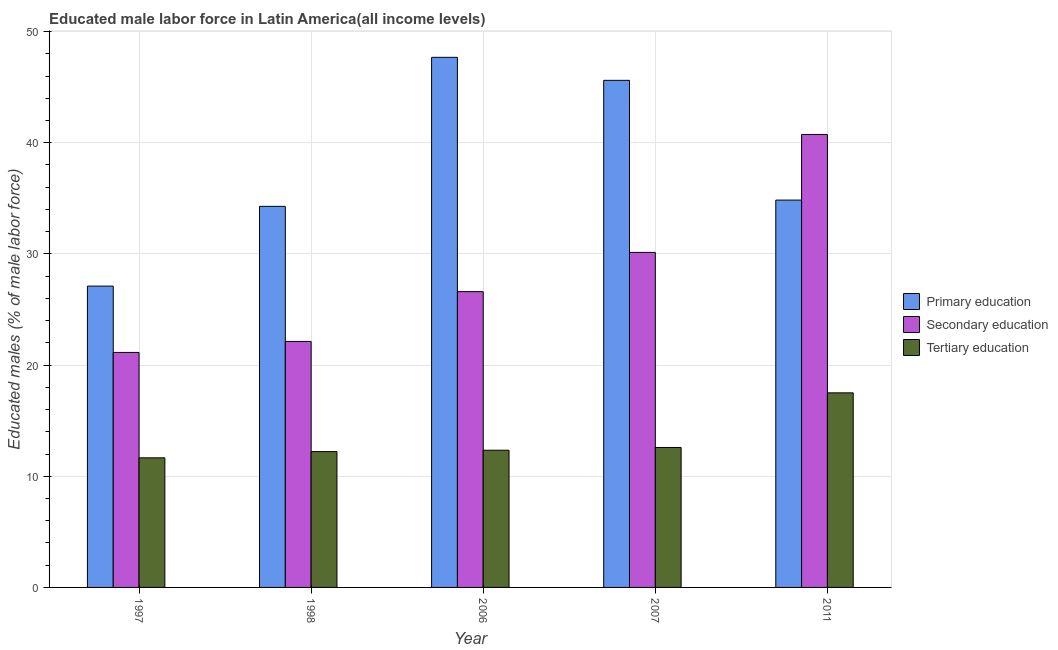How many groups of bars are there?
Provide a succinct answer. 5. Are the number of bars per tick equal to the number of legend labels?
Offer a very short reply. Yes. Are the number of bars on each tick of the X-axis equal?
Ensure brevity in your answer.  Yes. How many bars are there on the 5th tick from the left?
Make the answer very short. 3. What is the label of the 2nd group of bars from the left?
Ensure brevity in your answer.  1998. What is the percentage of male labor force who received secondary education in 2006?
Ensure brevity in your answer.  26.6. Across all years, what is the maximum percentage of male labor force who received tertiary education?
Offer a very short reply. 17.5. Across all years, what is the minimum percentage of male labor force who received primary education?
Your answer should be very brief. 27.1. In which year was the percentage of male labor force who received tertiary education maximum?
Provide a succinct answer. 2011. In which year was the percentage of male labor force who received primary education minimum?
Give a very brief answer. 1997. What is the total percentage of male labor force who received tertiary education in the graph?
Your answer should be very brief. 66.3. What is the difference between the percentage of male labor force who received primary education in 1997 and that in 2007?
Provide a short and direct response. -18.51. What is the difference between the percentage of male labor force who received tertiary education in 2007 and the percentage of male labor force who received secondary education in 2006?
Provide a succinct answer. 0.25. What is the average percentage of male labor force who received secondary education per year?
Your answer should be compact. 28.15. In the year 2007, what is the difference between the percentage of male labor force who received secondary education and percentage of male labor force who received tertiary education?
Provide a succinct answer. 0. In how many years, is the percentage of male labor force who received primary education greater than 8 %?
Give a very brief answer. 5. What is the ratio of the percentage of male labor force who received secondary education in 2006 to that in 2011?
Offer a very short reply. 0.65. Is the percentage of male labor force who received secondary education in 1998 less than that in 2007?
Offer a terse response. Yes. What is the difference between the highest and the second highest percentage of male labor force who received tertiary education?
Your response must be concise. 4.91. What is the difference between the highest and the lowest percentage of male labor force who received secondary education?
Provide a short and direct response. 19.61. Is the sum of the percentage of male labor force who received tertiary education in 1997 and 2006 greater than the maximum percentage of male labor force who received primary education across all years?
Ensure brevity in your answer.  Yes. What does the 2nd bar from the left in 1997 represents?
Make the answer very short. Secondary education. Is it the case that in every year, the sum of the percentage of male labor force who received primary education and percentage of male labor force who received secondary education is greater than the percentage of male labor force who received tertiary education?
Keep it short and to the point. Yes. How many bars are there?
Ensure brevity in your answer.  15. Are the values on the major ticks of Y-axis written in scientific E-notation?
Offer a terse response. No. Does the graph contain any zero values?
Provide a short and direct response. No. Does the graph contain grids?
Provide a short and direct response. Yes. How many legend labels are there?
Ensure brevity in your answer.  3. What is the title of the graph?
Give a very brief answer. Educated male labor force in Latin America(all income levels). Does "Agricultural Nitrous Oxide" appear as one of the legend labels in the graph?
Make the answer very short. No. What is the label or title of the X-axis?
Offer a terse response. Year. What is the label or title of the Y-axis?
Ensure brevity in your answer.  Educated males (% of male labor force). What is the Educated males (% of male labor force) of Primary education in 1997?
Provide a succinct answer. 27.1. What is the Educated males (% of male labor force) of Secondary education in 1997?
Make the answer very short. 21.14. What is the Educated males (% of male labor force) of Tertiary education in 1997?
Give a very brief answer. 11.66. What is the Educated males (% of male labor force) in Primary education in 1998?
Give a very brief answer. 34.28. What is the Educated males (% of male labor force) of Secondary education in 1998?
Your answer should be very brief. 22.13. What is the Educated males (% of male labor force) in Tertiary education in 1998?
Your answer should be very brief. 12.22. What is the Educated males (% of male labor force) of Primary education in 2006?
Offer a very short reply. 47.68. What is the Educated males (% of male labor force) in Secondary education in 2006?
Provide a succinct answer. 26.6. What is the Educated males (% of male labor force) of Tertiary education in 2006?
Ensure brevity in your answer.  12.34. What is the Educated males (% of male labor force) in Primary education in 2007?
Your answer should be very brief. 45.61. What is the Educated males (% of male labor force) of Secondary education in 2007?
Ensure brevity in your answer.  30.13. What is the Educated males (% of male labor force) in Tertiary education in 2007?
Provide a short and direct response. 12.59. What is the Educated males (% of male labor force) in Primary education in 2011?
Your answer should be compact. 34.84. What is the Educated males (% of male labor force) in Secondary education in 2011?
Your answer should be very brief. 40.74. What is the Educated males (% of male labor force) of Tertiary education in 2011?
Keep it short and to the point. 17.5. Across all years, what is the maximum Educated males (% of male labor force) of Primary education?
Make the answer very short. 47.68. Across all years, what is the maximum Educated males (% of male labor force) of Secondary education?
Your answer should be very brief. 40.74. Across all years, what is the maximum Educated males (% of male labor force) of Tertiary education?
Provide a succinct answer. 17.5. Across all years, what is the minimum Educated males (% of male labor force) of Primary education?
Offer a terse response. 27.1. Across all years, what is the minimum Educated males (% of male labor force) of Secondary education?
Your answer should be very brief. 21.14. Across all years, what is the minimum Educated males (% of male labor force) in Tertiary education?
Offer a very short reply. 11.66. What is the total Educated males (% of male labor force) in Primary education in the graph?
Ensure brevity in your answer.  189.51. What is the total Educated males (% of male labor force) of Secondary education in the graph?
Provide a succinct answer. 140.74. What is the total Educated males (% of male labor force) of Tertiary education in the graph?
Provide a short and direct response. 66.3. What is the difference between the Educated males (% of male labor force) of Primary education in 1997 and that in 1998?
Your answer should be compact. -7.17. What is the difference between the Educated males (% of male labor force) of Secondary education in 1997 and that in 1998?
Give a very brief answer. -0.99. What is the difference between the Educated males (% of male labor force) in Tertiary education in 1997 and that in 1998?
Provide a succinct answer. -0.56. What is the difference between the Educated males (% of male labor force) of Primary education in 1997 and that in 2006?
Make the answer very short. -20.58. What is the difference between the Educated males (% of male labor force) of Secondary education in 1997 and that in 2006?
Ensure brevity in your answer.  -5.47. What is the difference between the Educated males (% of male labor force) in Tertiary education in 1997 and that in 2006?
Your response must be concise. -0.68. What is the difference between the Educated males (% of male labor force) in Primary education in 1997 and that in 2007?
Your answer should be compact. -18.51. What is the difference between the Educated males (% of male labor force) in Secondary education in 1997 and that in 2007?
Give a very brief answer. -9. What is the difference between the Educated males (% of male labor force) in Tertiary education in 1997 and that in 2007?
Give a very brief answer. -0.93. What is the difference between the Educated males (% of male labor force) of Primary education in 1997 and that in 2011?
Your answer should be compact. -7.74. What is the difference between the Educated males (% of male labor force) in Secondary education in 1997 and that in 2011?
Your response must be concise. -19.61. What is the difference between the Educated males (% of male labor force) in Tertiary education in 1997 and that in 2011?
Offer a very short reply. -5.84. What is the difference between the Educated males (% of male labor force) of Primary education in 1998 and that in 2006?
Ensure brevity in your answer.  -13.4. What is the difference between the Educated males (% of male labor force) of Secondary education in 1998 and that in 2006?
Provide a succinct answer. -4.48. What is the difference between the Educated males (% of male labor force) in Tertiary education in 1998 and that in 2006?
Offer a very short reply. -0.12. What is the difference between the Educated males (% of male labor force) of Primary education in 1998 and that in 2007?
Your answer should be very brief. -11.33. What is the difference between the Educated males (% of male labor force) of Secondary education in 1998 and that in 2007?
Offer a very short reply. -8.01. What is the difference between the Educated males (% of male labor force) in Tertiary education in 1998 and that in 2007?
Give a very brief answer. -0.37. What is the difference between the Educated males (% of male labor force) in Primary education in 1998 and that in 2011?
Your answer should be compact. -0.56. What is the difference between the Educated males (% of male labor force) in Secondary education in 1998 and that in 2011?
Ensure brevity in your answer.  -18.62. What is the difference between the Educated males (% of male labor force) of Tertiary education in 1998 and that in 2011?
Offer a very short reply. -5.28. What is the difference between the Educated males (% of male labor force) in Primary education in 2006 and that in 2007?
Your answer should be compact. 2.07. What is the difference between the Educated males (% of male labor force) of Secondary education in 2006 and that in 2007?
Your response must be concise. -3.53. What is the difference between the Educated males (% of male labor force) of Tertiary education in 2006 and that in 2007?
Provide a short and direct response. -0.25. What is the difference between the Educated males (% of male labor force) in Primary education in 2006 and that in 2011?
Provide a short and direct response. 12.84. What is the difference between the Educated males (% of male labor force) in Secondary education in 2006 and that in 2011?
Give a very brief answer. -14.14. What is the difference between the Educated males (% of male labor force) of Tertiary education in 2006 and that in 2011?
Offer a terse response. -5.16. What is the difference between the Educated males (% of male labor force) in Primary education in 2007 and that in 2011?
Offer a terse response. 10.77. What is the difference between the Educated males (% of male labor force) of Secondary education in 2007 and that in 2011?
Make the answer very short. -10.61. What is the difference between the Educated males (% of male labor force) in Tertiary education in 2007 and that in 2011?
Provide a succinct answer. -4.91. What is the difference between the Educated males (% of male labor force) in Primary education in 1997 and the Educated males (% of male labor force) in Secondary education in 1998?
Provide a succinct answer. 4.98. What is the difference between the Educated males (% of male labor force) in Primary education in 1997 and the Educated males (% of male labor force) in Tertiary education in 1998?
Make the answer very short. 14.89. What is the difference between the Educated males (% of male labor force) of Secondary education in 1997 and the Educated males (% of male labor force) of Tertiary education in 1998?
Your response must be concise. 8.92. What is the difference between the Educated males (% of male labor force) of Primary education in 1997 and the Educated males (% of male labor force) of Secondary education in 2006?
Give a very brief answer. 0.5. What is the difference between the Educated males (% of male labor force) of Primary education in 1997 and the Educated males (% of male labor force) of Tertiary education in 2006?
Offer a very short reply. 14.76. What is the difference between the Educated males (% of male labor force) in Secondary education in 1997 and the Educated males (% of male labor force) in Tertiary education in 2006?
Your response must be concise. 8.8. What is the difference between the Educated males (% of male labor force) of Primary education in 1997 and the Educated males (% of male labor force) of Secondary education in 2007?
Ensure brevity in your answer.  -3.03. What is the difference between the Educated males (% of male labor force) in Primary education in 1997 and the Educated males (% of male labor force) in Tertiary education in 2007?
Offer a terse response. 14.52. What is the difference between the Educated males (% of male labor force) of Secondary education in 1997 and the Educated males (% of male labor force) of Tertiary education in 2007?
Provide a short and direct response. 8.55. What is the difference between the Educated males (% of male labor force) in Primary education in 1997 and the Educated males (% of male labor force) in Secondary education in 2011?
Your response must be concise. -13.64. What is the difference between the Educated males (% of male labor force) of Primary education in 1997 and the Educated males (% of male labor force) of Tertiary education in 2011?
Make the answer very short. 9.6. What is the difference between the Educated males (% of male labor force) of Secondary education in 1997 and the Educated males (% of male labor force) of Tertiary education in 2011?
Offer a terse response. 3.64. What is the difference between the Educated males (% of male labor force) of Primary education in 1998 and the Educated males (% of male labor force) of Secondary education in 2006?
Provide a short and direct response. 7.67. What is the difference between the Educated males (% of male labor force) in Primary education in 1998 and the Educated males (% of male labor force) in Tertiary education in 2006?
Ensure brevity in your answer.  21.94. What is the difference between the Educated males (% of male labor force) in Secondary education in 1998 and the Educated males (% of male labor force) in Tertiary education in 2006?
Offer a terse response. 9.79. What is the difference between the Educated males (% of male labor force) of Primary education in 1998 and the Educated males (% of male labor force) of Secondary education in 2007?
Provide a succinct answer. 4.14. What is the difference between the Educated males (% of male labor force) of Primary education in 1998 and the Educated males (% of male labor force) of Tertiary education in 2007?
Keep it short and to the point. 21.69. What is the difference between the Educated males (% of male labor force) of Secondary education in 1998 and the Educated males (% of male labor force) of Tertiary education in 2007?
Your response must be concise. 9.54. What is the difference between the Educated males (% of male labor force) in Primary education in 1998 and the Educated males (% of male labor force) in Secondary education in 2011?
Your response must be concise. -6.47. What is the difference between the Educated males (% of male labor force) of Primary education in 1998 and the Educated males (% of male labor force) of Tertiary education in 2011?
Make the answer very short. 16.77. What is the difference between the Educated males (% of male labor force) in Secondary education in 1998 and the Educated males (% of male labor force) in Tertiary education in 2011?
Offer a terse response. 4.63. What is the difference between the Educated males (% of male labor force) of Primary education in 2006 and the Educated males (% of male labor force) of Secondary education in 2007?
Your answer should be very brief. 17.55. What is the difference between the Educated males (% of male labor force) in Primary education in 2006 and the Educated males (% of male labor force) in Tertiary education in 2007?
Your answer should be compact. 35.09. What is the difference between the Educated males (% of male labor force) of Secondary education in 2006 and the Educated males (% of male labor force) of Tertiary education in 2007?
Your answer should be compact. 14.02. What is the difference between the Educated males (% of male labor force) of Primary education in 2006 and the Educated males (% of male labor force) of Secondary education in 2011?
Provide a succinct answer. 6.94. What is the difference between the Educated males (% of male labor force) in Primary education in 2006 and the Educated males (% of male labor force) in Tertiary education in 2011?
Make the answer very short. 30.18. What is the difference between the Educated males (% of male labor force) in Secondary education in 2006 and the Educated males (% of male labor force) in Tertiary education in 2011?
Keep it short and to the point. 9.1. What is the difference between the Educated males (% of male labor force) of Primary education in 2007 and the Educated males (% of male labor force) of Secondary education in 2011?
Ensure brevity in your answer.  4.87. What is the difference between the Educated males (% of male labor force) of Primary education in 2007 and the Educated males (% of male labor force) of Tertiary education in 2011?
Give a very brief answer. 28.11. What is the difference between the Educated males (% of male labor force) of Secondary education in 2007 and the Educated males (% of male labor force) of Tertiary education in 2011?
Provide a short and direct response. 12.63. What is the average Educated males (% of male labor force) of Primary education per year?
Keep it short and to the point. 37.9. What is the average Educated males (% of male labor force) of Secondary education per year?
Ensure brevity in your answer.  28.15. What is the average Educated males (% of male labor force) of Tertiary education per year?
Provide a succinct answer. 13.26. In the year 1997, what is the difference between the Educated males (% of male labor force) in Primary education and Educated males (% of male labor force) in Secondary education?
Make the answer very short. 5.97. In the year 1997, what is the difference between the Educated males (% of male labor force) in Primary education and Educated males (% of male labor force) in Tertiary education?
Offer a very short reply. 15.45. In the year 1997, what is the difference between the Educated males (% of male labor force) of Secondary education and Educated males (% of male labor force) of Tertiary education?
Provide a succinct answer. 9.48. In the year 1998, what is the difference between the Educated males (% of male labor force) of Primary education and Educated males (% of male labor force) of Secondary education?
Keep it short and to the point. 12.15. In the year 1998, what is the difference between the Educated males (% of male labor force) in Primary education and Educated males (% of male labor force) in Tertiary education?
Ensure brevity in your answer.  22.06. In the year 1998, what is the difference between the Educated males (% of male labor force) in Secondary education and Educated males (% of male labor force) in Tertiary education?
Offer a terse response. 9.91. In the year 2006, what is the difference between the Educated males (% of male labor force) of Primary education and Educated males (% of male labor force) of Secondary education?
Provide a short and direct response. 21.08. In the year 2006, what is the difference between the Educated males (% of male labor force) in Primary education and Educated males (% of male labor force) in Tertiary education?
Your response must be concise. 35.34. In the year 2006, what is the difference between the Educated males (% of male labor force) of Secondary education and Educated males (% of male labor force) of Tertiary education?
Provide a succinct answer. 14.26. In the year 2007, what is the difference between the Educated males (% of male labor force) of Primary education and Educated males (% of male labor force) of Secondary education?
Provide a succinct answer. 15.48. In the year 2007, what is the difference between the Educated males (% of male labor force) in Primary education and Educated males (% of male labor force) in Tertiary education?
Your answer should be compact. 33.02. In the year 2007, what is the difference between the Educated males (% of male labor force) in Secondary education and Educated males (% of male labor force) in Tertiary education?
Your response must be concise. 17.55. In the year 2011, what is the difference between the Educated males (% of male labor force) of Primary education and Educated males (% of male labor force) of Secondary education?
Keep it short and to the point. -5.9. In the year 2011, what is the difference between the Educated males (% of male labor force) in Primary education and Educated males (% of male labor force) in Tertiary education?
Your answer should be very brief. 17.34. In the year 2011, what is the difference between the Educated males (% of male labor force) of Secondary education and Educated males (% of male labor force) of Tertiary education?
Offer a terse response. 23.24. What is the ratio of the Educated males (% of male labor force) in Primary education in 1997 to that in 1998?
Your answer should be compact. 0.79. What is the ratio of the Educated males (% of male labor force) of Secondary education in 1997 to that in 1998?
Provide a short and direct response. 0.96. What is the ratio of the Educated males (% of male labor force) in Tertiary education in 1997 to that in 1998?
Your answer should be compact. 0.95. What is the ratio of the Educated males (% of male labor force) in Primary education in 1997 to that in 2006?
Provide a short and direct response. 0.57. What is the ratio of the Educated males (% of male labor force) of Secondary education in 1997 to that in 2006?
Provide a succinct answer. 0.79. What is the ratio of the Educated males (% of male labor force) of Tertiary education in 1997 to that in 2006?
Ensure brevity in your answer.  0.94. What is the ratio of the Educated males (% of male labor force) in Primary education in 1997 to that in 2007?
Provide a succinct answer. 0.59. What is the ratio of the Educated males (% of male labor force) of Secondary education in 1997 to that in 2007?
Provide a short and direct response. 0.7. What is the ratio of the Educated males (% of male labor force) of Tertiary education in 1997 to that in 2007?
Your response must be concise. 0.93. What is the ratio of the Educated males (% of male labor force) in Primary education in 1997 to that in 2011?
Give a very brief answer. 0.78. What is the ratio of the Educated males (% of male labor force) in Secondary education in 1997 to that in 2011?
Provide a succinct answer. 0.52. What is the ratio of the Educated males (% of male labor force) in Tertiary education in 1997 to that in 2011?
Offer a terse response. 0.67. What is the ratio of the Educated males (% of male labor force) of Primary education in 1998 to that in 2006?
Your answer should be very brief. 0.72. What is the ratio of the Educated males (% of male labor force) of Secondary education in 1998 to that in 2006?
Your response must be concise. 0.83. What is the ratio of the Educated males (% of male labor force) of Primary education in 1998 to that in 2007?
Give a very brief answer. 0.75. What is the ratio of the Educated males (% of male labor force) in Secondary education in 1998 to that in 2007?
Ensure brevity in your answer.  0.73. What is the ratio of the Educated males (% of male labor force) in Tertiary education in 1998 to that in 2007?
Your answer should be very brief. 0.97. What is the ratio of the Educated males (% of male labor force) in Primary education in 1998 to that in 2011?
Ensure brevity in your answer.  0.98. What is the ratio of the Educated males (% of male labor force) in Secondary education in 1998 to that in 2011?
Ensure brevity in your answer.  0.54. What is the ratio of the Educated males (% of male labor force) in Tertiary education in 1998 to that in 2011?
Provide a succinct answer. 0.7. What is the ratio of the Educated males (% of male labor force) in Primary education in 2006 to that in 2007?
Your answer should be very brief. 1.05. What is the ratio of the Educated males (% of male labor force) of Secondary education in 2006 to that in 2007?
Provide a succinct answer. 0.88. What is the ratio of the Educated males (% of male labor force) in Tertiary education in 2006 to that in 2007?
Keep it short and to the point. 0.98. What is the ratio of the Educated males (% of male labor force) in Primary education in 2006 to that in 2011?
Offer a terse response. 1.37. What is the ratio of the Educated males (% of male labor force) of Secondary education in 2006 to that in 2011?
Make the answer very short. 0.65. What is the ratio of the Educated males (% of male labor force) of Tertiary education in 2006 to that in 2011?
Your response must be concise. 0.71. What is the ratio of the Educated males (% of male labor force) of Primary education in 2007 to that in 2011?
Your answer should be compact. 1.31. What is the ratio of the Educated males (% of male labor force) of Secondary education in 2007 to that in 2011?
Your answer should be very brief. 0.74. What is the ratio of the Educated males (% of male labor force) of Tertiary education in 2007 to that in 2011?
Your response must be concise. 0.72. What is the difference between the highest and the second highest Educated males (% of male labor force) of Primary education?
Provide a short and direct response. 2.07. What is the difference between the highest and the second highest Educated males (% of male labor force) in Secondary education?
Your answer should be compact. 10.61. What is the difference between the highest and the second highest Educated males (% of male labor force) in Tertiary education?
Your answer should be very brief. 4.91. What is the difference between the highest and the lowest Educated males (% of male labor force) of Primary education?
Make the answer very short. 20.58. What is the difference between the highest and the lowest Educated males (% of male labor force) in Secondary education?
Give a very brief answer. 19.61. What is the difference between the highest and the lowest Educated males (% of male labor force) of Tertiary education?
Your answer should be very brief. 5.84. 